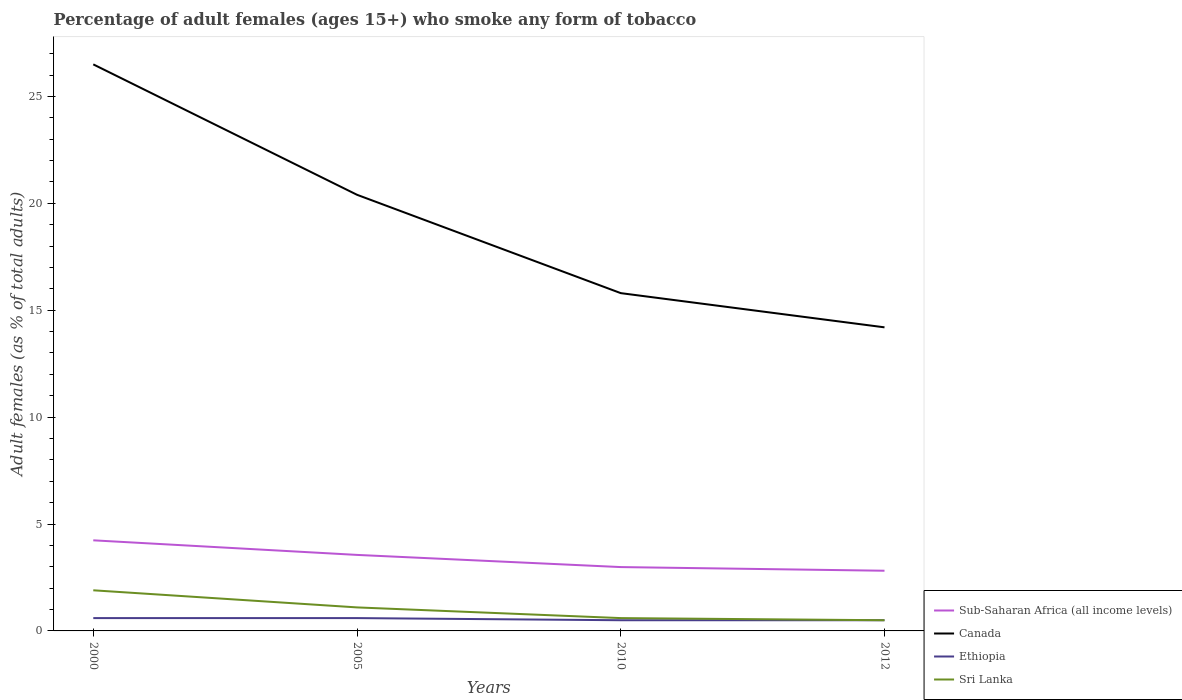Does the line corresponding to Sub-Saharan Africa (all income levels) intersect with the line corresponding to Canada?
Provide a succinct answer. No. Across all years, what is the maximum percentage of adult females who smoke in Canada?
Give a very brief answer. 14.2. In which year was the percentage of adult females who smoke in Canada maximum?
Offer a terse response. 2012. What is the total percentage of adult females who smoke in Ethiopia in the graph?
Offer a very short reply. 0.1. What is the difference between the highest and the second highest percentage of adult females who smoke in Ethiopia?
Make the answer very short. 0.1. What is the difference between the highest and the lowest percentage of adult females who smoke in Canada?
Your answer should be compact. 2. Is the percentage of adult females who smoke in Ethiopia strictly greater than the percentage of adult females who smoke in Sri Lanka over the years?
Provide a succinct answer. No. How many years are there in the graph?
Offer a very short reply. 4. Are the values on the major ticks of Y-axis written in scientific E-notation?
Keep it short and to the point. No. Does the graph contain any zero values?
Make the answer very short. No. Does the graph contain grids?
Your answer should be compact. No. Where does the legend appear in the graph?
Keep it short and to the point. Bottom right. How many legend labels are there?
Your answer should be compact. 4. What is the title of the graph?
Your answer should be very brief. Percentage of adult females (ages 15+) who smoke any form of tobacco. Does "Samoa" appear as one of the legend labels in the graph?
Your response must be concise. No. What is the label or title of the X-axis?
Your answer should be compact. Years. What is the label or title of the Y-axis?
Provide a succinct answer. Adult females (as % of total adults). What is the Adult females (as % of total adults) in Sub-Saharan Africa (all income levels) in 2000?
Your answer should be compact. 4.24. What is the Adult females (as % of total adults) of Canada in 2000?
Your response must be concise. 26.5. What is the Adult females (as % of total adults) of Ethiopia in 2000?
Give a very brief answer. 0.6. What is the Adult females (as % of total adults) in Sri Lanka in 2000?
Make the answer very short. 1.9. What is the Adult females (as % of total adults) of Sub-Saharan Africa (all income levels) in 2005?
Provide a succinct answer. 3.56. What is the Adult females (as % of total adults) of Canada in 2005?
Offer a terse response. 20.4. What is the Adult females (as % of total adults) of Sub-Saharan Africa (all income levels) in 2010?
Provide a short and direct response. 2.99. What is the Adult females (as % of total adults) of Sub-Saharan Africa (all income levels) in 2012?
Make the answer very short. 2.81. What is the Adult females (as % of total adults) in Canada in 2012?
Offer a very short reply. 14.2. What is the Adult females (as % of total adults) in Ethiopia in 2012?
Your answer should be compact. 0.5. Across all years, what is the maximum Adult females (as % of total adults) in Sub-Saharan Africa (all income levels)?
Provide a succinct answer. 4.24. Across all years, what is the maximum Adult females (as % of total adults) in Ethiopia?
Your answer should be very brief. 0.6. Across all years, what is the maximum Adult females (as % of total adults) of Sri Lanka?
Your answer should be compact. 1.9. Across all years, what is the minimum Adult females (as % of total adults) in Sub-Saharan Africa (all income levels)?
Ensure brevity in your answer.  2.81. Across all years, what is the minimum Adult females (as % of total adults) in Canada?
Provide a short and direct response. 14.2. Across all years, what is the minimum Adult females (as % of total adults) of Ethiopia?
Make the answer very short. 0.5. Across all years, what is the minimum Adult females (as % of total adults) in Sri Lanka?
Offer a very short reply. 0.5. What is the total Adult females (as % of total adults) of Sub-Saharan Africa (all income levels) in the graph?
Give a very brief answer. 13.59. What is the total Adult females (as % of total adults) in Canada in the graph?
Offer a terse response. 76.9. What is the total Adult females (as % of total adults) in Sri Lanka in the graph?
Make the answer very short. 4.1. What is the difference between the Adult females (as % of total adults) of Sub-Saharan Africa (all income levels) in 2000 and that in 2005?
Your answer should be compact. 0.68. What is the difference between the Adult females (as % of total adults) of Canada in 2000 and that in 2005?
Offer a very short reply. 6.1. What is the difference between the Adult females (as % of total adults) in Sri Lanka in 2000 and that in 2005?
Make the answer very short. 0.8. What is the difference between the Adult females (as % of total adults) in Sub-Saharan Africa (all income levels) in 2000 and that in 2010?
Make the answer very short. 1.25. What is the difference between the Adult females (as % of total adults) of Sub-Saharan Africa (all income levels) in 2000 and that in 2012?
Offer a very short reply. 1.42. What is the difference between the Adult females (as % of total adults) in Canada in 2000 and that in 2012?
Your response must be concise. 12.3. What is the difference between the Adult females (as % of total adults) of Ethiopia in 2000 and that in 2012?
Your answer should be compact. 0.1. What is the difference between the Adult females (as % of total adults) of Sub-Saharan Africa (all income levels) in 2005 and that in 2010?
Make the answer very short. 0.57. What is the difference between the Adult females (as % of total adults) in Ethiopia in 2005 and that in 2010?
Your answer should be very brief. 0.1. What is the difference between the Adult females (as % of total adults) in Sri Lanka in 2005 and that in 2010?
Make the answer very short. 0.5. What is the difference between the Adult females (as % of total adults) of Sub-Saharan Africa (all income levels) in 2005 and that in 2012?
Your answer should be compact. 0.74. What is the difference between the Adult females (as % of total adults) in Canada in 2005 and that in 2012?
Your response must be concise. 6.2. What is the difference between the Adult females (as % of total adults) in Sub-Saharan Africa (all income levels) in 2010 and that in 2012?
Provide a succinct answer. 0.17. What is the difference between the Adult females (as % of total adults) of Ethiopia in 2010 and that in 2012?
Offer a terse response. 0. What is the difference between the Adult females (as % of total adults) in Sri Lanka in 2010 and that in 2012?
Your answer should be compact. 0.1. What is the difference between the Adult females (as % of total adults) of Sub-Saharan Africa (all income levels) in 2000 and the Adult females (as % of total adults) of Canada in 2005?
Ensure brevity in your answer.  -16.16. What is the difference between the Adult females (as % of total adults) of Sub-Saharan Africa (all income levels) in 2000 and the Adult females (as % of total adults) of Ethiopia in 2005?
Offer a terse response. 3.64. What is the difference between the Adult females (as % of total adults) of Sub-Saharan Africa (all income levels) in 2000 and the Adult females (as % of total adults) of Sri Lanka in 2005?
Make the answer very short. 3.14. What is the difference between the Adult females (as % of total adults) of Canada in 2000 and the Adult females (as % of total adults) of Ethiopia in 2005?
Your answer should be very brief. 25.9. What is the difference between the Adult females (as % of total adults) in Canada in 2000 and the Adult females (as % of total adults) in Sri Lanka in 2005?
Keep it short and to the point. 25.4. What is the difference between the Adult females (as % of total adults) of Sub-Saharan Africa (all income levels) in 2000 and the Adult females (as % of total adults) of Canada in 2010?
Offer a very short reply. -11.56. What is the difference between the Adult females (as % of total adults) of Sub-Saharan Africa (all income levels) in 2000 and the Adult females (as % of total adults) of Ethiopia in 2010?
Provide a short and direct response. 3.74. What is the difference between the Adult females (as % of total adults) in Sub-Saharan Africa (all income levels) in 2000 and the Adult females (as % of total adults) in Sri Lanka in 2010?
Keep it short and to the point. 3.64. What is the difference between the Adult females (as % of total adults) of Canada in 2000 and the Adult females (as % of total adults) of Sri Lanka in 2010?
Your answer should be very brief. 25.9. What is the difference between the Adult females (as % of total adults) in Ethiopia in 2000 and the Adult females (as % of total adults) in Sri Lanka in 2010?
Offer a very short reply. 0. What is the difference between the Adult females (as % of total adults) in Sub-Saharan Africa (all income levels) in 2000 and the Adult females (as % of total adults) in Canada in 2012?
Offer a terse response. -9.96. What is the difference between the Adult females (as % of total adults) in Sub-Saharan Africa (all income levels) in 2000 and the Adult females (as % of total adults) in Ethiopia in 2012?
Ensure brevity in your answer.  3.74. What is the difference between the Adult females (as % of total adults) of Sub-Saharan Africa (all income levels) in 2000 and the Adult females (as % of total adults) of Sri Lanka in 2012?
Your response must be concise. 3.74. What is the difference between the Adult females (as % of total adults) of Canada in 2000 and the Adult females (as % of total adults) of Ethiopia in 2012?
Your answer should be very brief. 26. What is the difference between the Adult females (as % of total adults) in Sub-Saharan Africa (all income levels) in 2005 and the Adult females (as % of total adults) in Canada in 2010?
Your answer should be very brief. -12.24. What is the difference between the Adult females (as % of total adults) in Sub-Saharan Africa (all income levels) in 2005 and the Adult females (as % of total adults) in Ethiopia in 2010?
Ensure brevity in your answer.  3.06. What is the difference between the Adult females (as % of total adults) of Sub-Saharan Africa (all income levels) in 2005 and the Adult females (as % of total adults) of Sri Lanka in 2010?
Make the answer very short. 2.96. What is the difference between the Adult females (as % of total adults) in Canada in 2005 and the Adult females (as % of total adults) in Sri Lanka in 2010?
Provide a succinct answer. 19.8. What is the difference between the Adult females (as % of total adults) in Sub-Saharan Africa (all income levels) in 2005 and the Adult females (as % of total adults) in Canada in 2012?
Your answer should be compact. -10.64. What is the difference between the Adult females (as % of total adults) in Sub-Saharan Africa (all income levels) in 2005 and the Adult females (as % of total adults) in Ethiopia in 2012?
Make the answer very short. 3.06. What is the difference between the Adult females (as % of total adults) in Sub-Saharan Africa (all income levels) in 2005 and the Adult females (as % of total adults) in Sri Lanka in 2012?
Make the answer very short. 3.06. What is the difference between the Adult females (as % of total adults) in Canada in 2005 and the Adult females (as % of total adults) in Ethiopia in 2012?
Your answer should be very brief. 19.9. What is the difference between the Adult females (as % of total adults) of Canada in 2005 and the Adult females (as % of total adults) of Sri Lanka in 2012?
Keep it short and to the point. 19.9. What is the difference between the Adult females (as % of total adults) of Ethiopia in 2005 and the Adult females (as % of total adults) of Sri Lanka in 2012?
Keep it short and to the point. 0.1. What is the difference between the Adult females (as % of total adults) of Sub-Saharan Africa (all income levels) in 2010 and the Adult females (as % of total adults) of Canada in 2012?
Your answer should be compact. -11.21. What is the difference between the Adult females (as % of total adults) in Sub-Saharan Africa (all income levels) in 2010 and the Adult females (as % of total adults) in Ethiopia in 2012?
Give a very brief answer. 2.49. What is the difference between the Adult females (as % of total adults) of Sub-Saharan Africa (all income levels) in 2010 and the Adult females (as % of total adults) of Sri Lanka in 2012?
Give a very brief answer. 2.49. What is the difference between the Adult females (as % of total adults) of Canada in 2010 and the Adult females (as % of total adults) of Ethiopia in 2012?
Offer a terse response. 15.3. What is the difference between the Adult females (as % of total adults) of Canada in 2010 and the Adult females (as % of total adults) of Sri Lanka in 2012?
Ensure brevity in your answer.  15.3. What is the difference between the Adult females (as % of total adults) in Ethiopia in 2010 and the Adult females (as % of total adults) in Sri Lanka in 2012?
Keep it short and to the point. 0. What is the average Adult females (as % of total adults) in Sub-Saharan Africa (all income levels) per year?
Keep it short and to the point. 3.4. What is the average Adult females (as % of total adults) of Canada per year?
Provide a succinct answer. 19.23. What is the average Adult females (as % of total adults) in Ethiopia per year?
Keep it short and to the point. 0.55. What is the average Adult females (as % of total adults) of Sri Lanka per year?
Offer a terse response. 1.02. In the year 2000, what is the difference between the Adult females (as % of total adults) of Sub-Saharan Africa (all income levels) and Adult females (as % of total adults) of Canada?
Your answer should be very brief. -22.26. In the year 2000, what is the difference between the Adult females (as % of total adults) in Sub-Saharan Africa (all income levels) and Adult females (as % of total adults) in Ethiopia?
Your answer should be very brief. 3.64. In the year 2000, what is the difference between the Adult females (as % of total adults) in Sub-Saharan Africa (all income levels) and Adult females (as % of total adults) in Sri Lanka?
Ensure brevity in your answer.  2.34. In the year 2000, what is the difference between the Adult females (as % of total adults) in Canada and Adult females (as % of total adults) in Ethiopia?
Make the answer very short. 25.9. In the year 2000, what is the difference between the Adult females (as % of total adults) of Canada and Adult females (as % of total adults) of Sri Lanka?
Keep it short and to the point. 24.6. In the year 2000, what is the difference between the Adult females (as % of total adults) in Ethiopia and Adult females (as % of total adults) in Sri Lanka?
Make the answer very short. -1.3. In the year 2005, what is the difference between the Adult females (as % of total adults) in Sub-Saharan Africa (all income levels) and Adult females (as % of total adults) in Canada?
Ensure brevity in your answer.  -16.84. In the year 2005, what is the difference between the Adult females (as % of total adults) in Sub-Saharan Africa (all income levels) and Adult females (as % of total adults) in Ethiopia?
Your answer should be compact. 2.96. In the year 2005, what is the difference between the Adult females (as % of total adults) in Sub-Saharan Africa (all income levels) and Adult females (as % of total adults) in Sri Lanka?
Ensure brevity in your answer.  2.46. In the year 2005, what is the difference between the Adult females (as % of total adults) of Canada and Adult females (as % of total adults) of Ethiopia?
Your response must be concise. 19.8. In the year 2005, what is the difference between the Adult females (as % of total adults) in Canada and Adult females (as % of total adults) in Sri Lanka?
Your answer should be very brief. 19.3. In the year 2005, what is the difference between the Adult females (as % of total adults) in Ethiopia and Adult females (as % of total adults) in Sri Lanka?
Ensure brevity in your answer.  -0.5. In the year 2010, what is the difference between the Adult females (as % of total adults) in Sub-Saharan Africa (all income levels) and Adult females (as % of total adults) in Canada?
Keep it short and to the point. -12.81. In the year 2010, what is the difference between the Adult females (as % of total adults) in Sub-Saharan Africa (all income levels) and Adult females (as % of total adults) in Ethiopia?
Give a very brief answer. 2.49. In the year 2010, what is the difference between the Adult females (as % of total adults) in Sub-Saharan Africa (all income levels) and Adult females (as % of total adults) in Sri Lanka?
Keep it short and to the point. 2.39. In the year 2010, what is the difference between the Adult females (as % of total adults) of Canada and Adult females (as % of total adults) of Ethiopia?
Offer a very short reply. 15.3. In the year 2010, what is the difference between the Adult females (as % of total adults) of Ethiopia and Adult females (as % of total adults) of Sri Lanka?
Ensure brevity in your answer.  -0.1. In the year 2012, what is the difference between the Adult females (as % of total adults) of Sub-Saharan Africa (all income levels) and Adult females (as % of total adults) of Canada?
Your response must be concise. -11.39. In the year 2012, what is the difference between the Adult females (as % of total adults) of Sub-Saharan Africa (all income levels) and Adult females (as % of total adults) of Ethiopia?
Make the answer very short. 2.31. In the year 2012, what is the difference between the Adult females (as % of total adults) of Sub-Saharan Africa (all income levels) and Adult females (as % of total adults) of Sri Lanka?
Make the answer very short. 2.31. What is the ratio of the Adult females (as % of total adults) of Sub-Saharan Africa (all income levels) in 2000 to that in 2005?
Make the answer very short. 1.19. What is the ratio of the Adult females (as % of total adults) of Canada in 2000 to that in 2005?
Provide a short and direct response. 1.3. What is the ratio of the Adult females (as % of total adults) in Sri Lanka in 2000 to that in 2005?
Ensure brevity in your answer.  1.73. What is the ratio of the Adult females (as % of total adults) in Sub-Saharan Africa (all income levels) in 2000 to that in 2010?
Offer a very short reply. 1.42. What is the ratio of the Adult females (as % of total adults) in Canada in 2000 to that in 2010?
Ensure brevity in your answer.  1.68. What is the ratio of the Adult females (as % of total adults) of Sri Lanka in 2000 to that in 2010?
Offer a very short reply. 3.17. What is the ratio of the Adult females (as % of total adults) in Sub-Saharan Africa (all income levels) in 2000 to that in 2012?
Make the answer very short. 1.51. What is the ratio of the Adult females (as % of total adults) in Canada in 2000 to that in 2012?
Provide a short and direct response. 1.87. What is the ratio of the Adult females (as % of total adults) of Ethiopia in 2000 to that in 2012?
Offer a terse response. 1.2. What is the ratio of the Adult females (as % of total adults) in Sub-Saharan Africa (all income levels) in 2005 to that in 2010?
Your response must be concise. 1.19. What is the ratio of the Adult females (as % of total adults) of Canada in 2005 to that in 2010?
Offer a very short reply. 1.29. What is the ratio of the Adult females (as % of total adults) in Ethiopia in 2005 to that in 2010?
Keep it short and to the point. 1.2. What is the ratio of the Adult females (as % of total adults) in Sri Lanka in 2005 to that in 2010?
Your answer should be very brief. 1.83. What is the ratio of the Adult females (as % of total adults) of Sub-Saharan Africa (all income levels) in 2005 to that in 2012?
Your answer should be very brief. 1.26. What is the ratio of the Adult females (as % of total adults) in Canada in 2005 to that in 2012?
Your answer should be compact. 1.44. What is the ratio of the Adult females (as % of total adults) in Sri Lanka in 2005 to that in 2012?
Your answer should be very brief. 2.2. What is the ratio of the Adult females (as % of total adults) of Sub-Saharan Africa (all income levels) in 2010 to that in 2012?
Make the answer very short. 1.06. What is the ratio of the Adult females (as % of total adults) in Canada in 2010 to that in 2012?
Offer a terse response. 1.11. What is the ratio of the Adult females (as % of total adults) in Ethiopia in 2010 to that in 2012?
Offer a very short reply. 1. What is the difference between the highest and the second highest Adult females (as % of total adults) in Sub-Saharan Africa (all income levels)?
Offer a very short reply. 0.68. What is the difference between the highest and the second highest Adult females (as % of total adults) in Canada?
Offer a very short reply. 6.1. What is the difference between the highest and the second highest Adult females (as % of total adults) of Ethiopia?
Your answer should be very brief. 0. What is the difference between the highest and the lowest Adult females (as % of total adults) of Sub-Saharan Africa (all income levels)?
Ensure brevity in your answer.  1.42. What is the difference between the highest and the lowest Adult females (as % of total adults) in Ethiopia?
Make the answer very short. 0.1. 